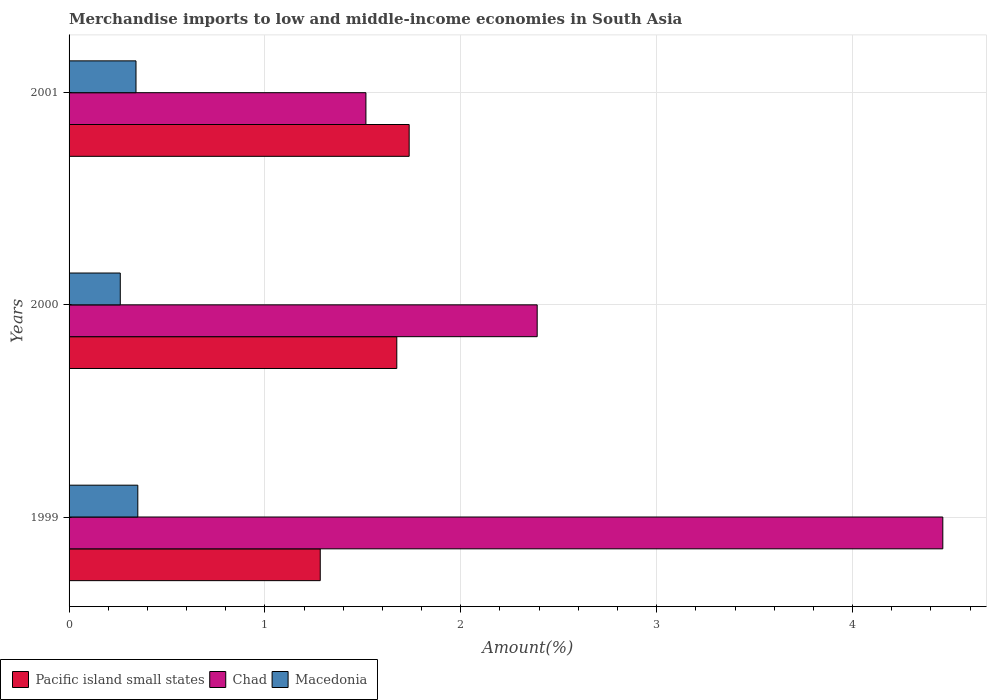How many different coloured bars are there?
Your answer should be very brief. 3. How many groups of bars are there?
Your answer should be compact. 3. How many bars are there on the 1st tick from the top?
Give a very brief answer. 3. In how many cases, is the number of bars for a given year not equal to the number of legend labels?
Give a very brief answer. 0. What is the percentage of amount earned from merchandise imports in Pacific island small states in 2001?
Keep it short and to the point. 1.74. Across all years, what is the maximum percentage of amount earned from merchandise imports in Macedonia?
Keep it short and to the point. 0.35. Across all years, what is the minimum percentage of amount earned from merchandise imports in Chad?
Your response must be concise. 1.52. What is the total percentage of amount earned from merchandise imports in Pacific island small states in the graph?
Give a very brief answer. 4.69. What is the difference between the percentage of amount earned from merchandise imports in Chad in 2000 and that in 2001?
Make the answer very short. 0.87. What is the difference between the percentage of amount earned from merchandise imports in Pacific island small states in 2001 and the percentage of amount earned from merchandise imports in Macedonia in 1999?
Give a very brief answer. 1.39. What is the average percentage of amount earned from merchandise imports in Pacific island small states per year?
Offer a very short reply. 1.56. In the year 2000, what is the difference between the percentage of amount earned from merchandise imports in Chad and percentage of amount earned from merchandise imports in Macedonia?
Keep it short and to the point. 2.13. In how many years, is the percentage of amount earned from merchandise imports in Chad greater than 2.6 %?
Your answer should be compact. 1. What is the ratio of the percentage of amount earned from merchandise imports in Pacific island small states in 1999 to that in 2001?
Provide a short and direct response. 0.74. Is the percentage of amount earned from merchandise imports in Chad in 1999 less than that in 2001?
Keep it short and to the point. No. Is the difference between the percentage of amount earned from merchandise imports in Chad in 1999 and 2000 greater than the difference between the percentage of amount earned from merchandise imports in Macedonia in 1999 and 2000?
Ensure brevity in your answer.  Yes. What is the difference between the highest and the second highest percentage of amount earned from merchandise imports in Pacific island small states?
Offer a terse response. 0.06. What is the difference between the highest and the lowest percentage of amount earned from merchandise imports in Chad?
Offer a very short reply. 2.95. What does the 1st bar from the top in 2001 represents?
Your answer should be very brief. Macedonia. What does the 2nd bar from the bottom in 2000 represents?
Your answer should be very brief. Chad. Is it the case that in every year, the sum of the percentage of amount earned from merchandise imports in Chad and percentage of amount earned from merchandise imports in Macedonia is greater than the percentage of amount earned from merchandise imports in Pacific island small states?
Provide a succinct answer. Yes. How many years are there in the graph?
Provide a succinct answer. 3. Does the graph contain any zero values?
Your answer should be very brief. No. How are the legend labels stacked?
Make the answer very short. Horizontal. What is the title of the graph?
Give a very brief answer. Merchandise imports to low and middle-income economies in South Asia. Does "New Zealand" appear as one of the legend labels in the graph?
Your answer should be very brief. No. What is the label or title of the X-axis?
Your answer should be compact. Amount(%). What is the Amount(%) of Pacific island small states in 1999?
Make the answer very short. 1.28. What is the Amount(%) of Chad in 1999?
Give a very brief answer. 4.46. What is the Amount(%) of Macedonia in 1999?
Make the answer very short. 0.35. What is the Amount(%) in Pacific island small states in 2000?
Provide a succinct answer. 1.67. What is the Amount(%) of Chad in 2000?
Provide a short and direct response. 2.39. What is the Amount(%) of Macedonia in 2000?
Make the answer very short. 0.26. What is the Amount(%) of Pacific island small states in 2001?
Your answer should be very brief. 1.74. What is the Amount(%) in Chad in 2001?
Make the answer very short. 1.52. What is the Amount(%) in Macedonia in 2001?
Your answer should be very brief. 0.34. Across all years, what is the maximum Amount(%) in Pacific island small states?
Give a very brief answer. 1.74. Across all years, what is the maximum Amount(%) in Chad?
Give a very brief answer. 4.46. Across all years, what is the maximum Amount(%) in Macedonia?
Give a very brief answer. 0.35. Across all years, what is the minimum Amount(%) in Pacific island small states?
Offer a terse response. 1.28. Across all years, what is the minimum Amount(%) in Chad?
Provide a succinct answer. 1.52. Across all years, what is the minimum Amount(%) in Macedonia?
Give a very brief answer. 0.26. What is the total Amount(%) in Pacific island small states in the graph?
Offer a very short reply. 4.69. What is the total Amount(%) in Chad in the graph?
Ensure brevity in your answer.  8.37. What is the total Amount(%) of Macedonia in the graph?
Your response must be concise. 0.95. What is the difference between the Amount(%) in Pacific island small states in 1999 and that in 2000?
Your response must be concise. -0.39. What is the difference between the Amount(%) in Chad in 1999 and that in 2000?
Provide a short and direct response. 2.07. What is the difference between the Amount(%) of Macedonia in 1999 and that in 2000?
Provide a succinct answer. 0.09. What is the difference between the Amount(%) in Pacific island small states in 1999 and that in 2001?
Ensure brevity in your answer.  -0.45. What is the difference between the Amount(%) of Chad in 1999 and that in 2001?
Ensure brevity in your answer.  2.95. What is the difference between the Amount(%) of Macedonia in 1999 and that in 2001?
Your answer should be compact. 0.01. What is the difference between the Amount(%) of Pacific island small states in 2000 and that in 2001?
Offer a terse response. -0.06. What is the difference between the Amount(%) in Chad in 2000 and that in 2001?
Ensure brevity in your answer.  0.87. What is the difference between the Amount(%) in Macedonia in 2000 and that in 2001?
Keep it short and to the point. -0.08. What is the difference between the Amount(%) of Pacific island small states in 1999 and the Amount(%) of Chad in 2000?
Offer a terse response. -1.11. What is the difference between the Amount(%) of Pacific island small states in 1999 and the Amount(%) of Macedonia in 2000?
Ensure brevity in your answer.  1.02. What is the difference between the Amount(%) in Chad in 1999 and the Amount(%) in Macedonia in 2000?
Your answer should be very brief. 4.2. What is the difference between the Amount(%) of Pacific island small states in 1999 and the Amount(%) of Chad in 2001?
Ensure brevity in your answer.  -0.23. What is the difference between the Amount(%) in Pacific island small states in 1999 and the Amount(%) in Macedonia in 2001?
Make the answer very short. 0.94. What is the difference between the Amount(%) of Chad in 1999 and the Amount(%) of Macedonia in 2001?
Your answer should be very brief. 4.12. What is the difference between the Amount(%) in Pacific island small states in 2000 and the Amount(%) in Chad in 2001?
Ensure brevity in your answer.  0.16. What is the difference between the Amount(%) in Pacific island small states in 2000 and the Amount(%) in Macedonia in 2001?
Offer a terse response. 1.33. What is the difference between the Amount(%) of Chad in 2000 and the Amount(%) of Macedonia in 2001?
Offer a terse response. 2.05. What is the average Amount(%) of Pacific island small states per year?
Ensure brevity in your answer.  1.56. What is the average Amount(%) in Chad per year?
Give a very brief answer. 2.79. What is the average Amount(%) in Macedonia per year?
Offer a very short reply. 0.32. In the year 1999, what is the difference between the Amount(%) in Pacific island small states and Amount(%) in Chad?
Your response must be concise. -3.18. In the year 1999, what is the difference between the Amount(%) in Pacific island small states and Amount(%) in Macedonia?
Offer a very short reply. 0.93. In the year 1999, what is the difference between the Amount(%) of Chad and Amount(%) of Macedonia?
Offer a terse response. 4.11. In the year 2000, what is the difference between the Amount(%) of Pacific island small states and Amount(%) of Chad?
Keep it short and to the point. -0.72. In the year 2000, what is the difference between the Amount(%) of Pacific island small states and Amount(%) of Macedonia?
Provide a short and direct response. 1.41. In the year 2000, what is the difference between the Amount(%) in Chad and Amount(%) in Macedonia?
Provide a short and direct response. 2.13. In the year 2001, what is the difference between the Amount(%) of Pacific island small states and Amount(%) of Chad?
Your answer should be very brief. 0.22. In the year 2001, what is the difference between the Amount(%) of Pacific island small states and Amount(%) of Macedonia?
Your response must be concise. 1.39. In the year 2001, what is the difference between the Amount(%) in Chad and Amount(%) in Macedonia?
Your response must be concise. 1.17. What is the ratio of the Amount(%) of Pacific island small states in 1999 to that in 2000?
Your answer should be very brief. 0.77. What is the ratio of the Amount(%) of Chad in 1999 to that in 2000?
Ensure brevity in your answer.  1.87. What is the ratio of the Amount(%) in Macedonia in 1999 to that in 2000?
Your answer should be very brief. 1.34. What is the ratio of the Amount(%) in Pacific island small states in 1999 to that in 2001?
Offer a very short reply. 0.74. What is the ratio of the Amount(%) in Chad in 1999 to that in 2001?
Your answer should be compact. 2.94. What is the ratio of the Amount(%) of Macedonia in 1999 to that in 2001?
Make the answer very short. 1.03. What is the ratio of the Amount(%) in Pacific island small states in 2000 to that in 2001?
Give a very brief answer. 0.96. What is the ratio of the Amount(%) of Chad in 2000 to that in 2001?
Keep it short and to the point. 1.58. What is the ratio of the Amount(%) of Macedonia in 2000 to that in 2001?
Provide a short and direct response. 0.77. What is the difference between the highest and the second highest Amount(%) in Pacific island small states?
Your answer should be compact. 0.06. What is the difference between the highest and the second highest Amount(%) of Chad?
Keep it short and to the point. 2.07. What is the difference between the highest and the second highest Amount(%) in Macedonia?
Keep it short and to the point. 0.01. What is the difference between the highest and the lowest Amount(%) in Pacific island small states?
Ensure brevity in your answer.  0.45. What is the difference between the highest and the lowest Amount(%) of Chad?
Keep it short and to the point. 2.95. What is the difference between the highest and the lowest Amount(%) of Macedonia?
Keep it short and to the point. 0.09. 